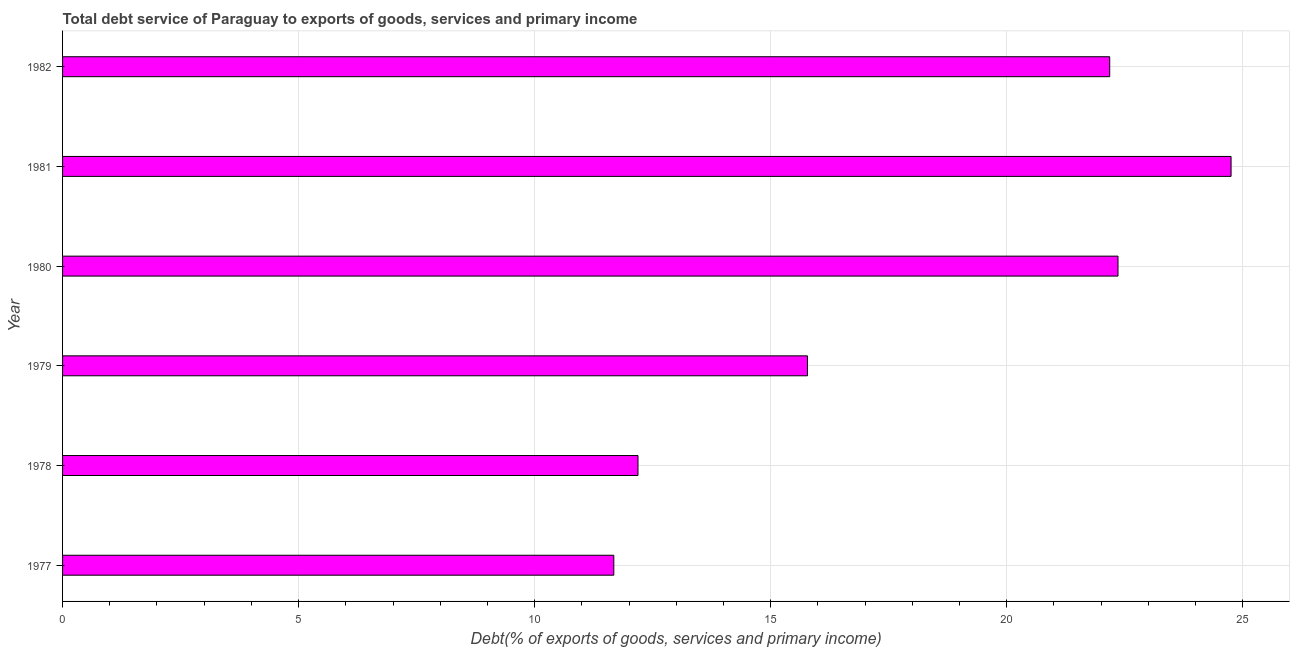What is the title of the graph?
Offer a terse response. Total debt service of Paraguay to exports of goods, services and primary income. What is the label or title of the X-axis?
Make the answer very short. Debt(% of exports of goods, services and primary income). What is the total debt service in 1979?
Provide a succinct answer. 15.78. Across all years, what is the maximum total debt service?
Ensure brevity in your answer.  24.75. Across all years, what is the minimum total debt service?
Your answer should be compact. 11.68. What is the sum of the total debt service?
Your response must be concise. 108.93. What is the difference between the total debt service in 1978 and 1979?
Offer a terse response. -3.59. What is the average total debt service per year?
Give a very brief answer. 18.16. What is the median total debt service?
Ensure brevity in your answer.  18.98. What is the ratio of the total debt service in 1978 to that in 1979?
Your response must be concise. 0.77. Is the total debt service in 1978 less than that in 1980?
Your response must be concise. Yes. What is the difference between the highest and the second highest total debt service?
Make the answer very short. 2.4. Is the sum of the total debt service in 1979 and 1980 greater than the maximum total debt service across all years?
Your answer should be very brief. Yes. What is the difference between the highest and the lowest total debt service?
Keep it short and to the point. 13.08. In how many years, is the total debt service greater than the average total debt service taken over all years?
Offer a very short reply. 3. How many bars are there?
Make the answer very short. 6. Are all the bars in the graph horizontal?
Give a very brief answer. Yes. Are the values on the major ticks of X-axis written in scientific E-notation?
Offer a terse response. No. What is the Debt(% of exports of goods, services and primary income) of 1977?
Ensure brevity in your answer.  11.68. What is the Debt(% of exports of goods, services and primary income) of 1978?
Ensure brevity in your answer.  12.19. What is the Debt(% of exports of goods, services and primary income) in 1979?
Your answer should be compact. 15.78. What is the Debt(% of exports of goods, services and primary income) in 1980?
Make the answer very short. 22.36. What is the Debt(% of exports of goods, services and primary income) in 1981?
Offer a terse response. 24.75. What is the Debt(% of exports of goods, services and primary income) of 1982?
Offer a terse response. 22.18. What is the difference between the Debt(% of exports of goods, services and primary income) in 1977 and 1978?
Make the answer very short. -0.51. What is the difference between the Debt(% of exports of goods, services and primary income) in 1977 and 1979?
Offer a very short reply. -4.1. What is the difference between the Debt(% of exports of goods, services and primary income) in 1977 and 1980?
Ensure brevity in your answer.  -10.68. What is the difference between the Debt(% of exports of goods, services and primary income) in 1977 and 1981?
Make the answer very short. -13.08. What is the difference between the Debt(% of exports of goods, services and primary income) in 1977 and 1982?
Your answer should be compact. -10.5. What is the difference between the Debt(% of exports of goods, services and primary income) in 1978 and 1979?
Provide a short and direct response. -3.59. What is the difference between the Debt(% of exports of goods, services and primary income) in 1978 and 1980?
Offer a very short reply. -10.17. What is the difference between the Debt(% of exports of goods, services and primary income) in 1978 and 1981?
Keep it short and to the point. -12.56. What is the difference between the Debt(% of exports of goods, services and primary income) in 1978 and 1982?
Offer a terse response. -9.99. What is the difference between the Debt(% of exports of goods, services and primary income) in 1979 and 1980?
Offer a terse response. -6.58. What is the difference between the Debt(% of exports of goods, services and primary income) in 1979 and 1981?
Your answer should be very brief. -8.97. What is the difference between the Debt(% of exports of goods, services and primary income) in 1979 and 1982?
Keep it short and to the point. -6.4. What is the difference between the Debt(% of exports of goods, services and primary income) in 1980 and 1981?
Give a very brief answer. -2.4. What is the difference between the Debt(% of exports of goods, services and primary income) in 1980 and 1982?
Provide a succinct answer. 0.18. What is the difference between the Debt(% of exports of goods, services and primary income) in 1981 and 1982?
Provide a short and direct response. 2.57. What is the ratio of the Debt(% of exports of goods, services and primary income) in 1977 to that in 1978?
Offer a terse response. 0.96. What is the ratio of the Debt(% of exports of goods, services and primary income) in 1977 to that in 1979?
Your answer should be very brief. 0.74. What is the ratio of the Debt(% of exports of goods, services and primary income) in 1977 to that in 1980?
Keep it short and to the point. 0.52. What is the ratio of the Debt(% of exports of goods, services and primary income) in 1977 to that in 1981?
Your answer should be compact. 0.47. What is the ratio of the Debt(% of exports of goods, services and primary income) in 1977 to that in 1982?
Provide a short and direct response. 0.53. What is the ratio of the Debt(% of exports of goods, services and primary income) in 1978 to that in 1979?
Offer a terse response. 0.77. What is the ratio of the Debt(% of exports of goods, services and primary income) in 1978 to that in 1980?
Your answer should be very brief. 0.55. What is the ratio of the Debt(% of exports of goods, services and primary income) in 1978 to that in 1981?
Your answer should be compact. 0.49. What is the ratio of the Debt(% of exports of goods, services and primary income) in 1978 to that in 1982?
Offer a terse response. 0.55. What is the ratio of the Debt(% of exports of goods, services and primary income) in 1979 to that in 1980?
Offer a terse response. 0.71. What is the ratio of the Debt(% of exports of goods, services and primary income) in 1979 to that in 1981?
Offer a terse response. 0.64. What is the ratio of the Debt(% of exports of goods, services and primary income) in 1979 to that in 1982?
Provide a short and direct response. 0.71. What is the ratio of the Debt(% of exports of goods, services and primary income) in 1980 to that in 1981?
Offer a very short reply. 0.9. What is the ratio of the Debt(% of exports of goods, services and primary income) in 1980 to that in 1982?
Provide a succinct answer. 1.01. What is the ratio of the Debt(% of exports of goods, services and primary income) in 1981 to that in 1982?
Make the answer very short. 1.12. 